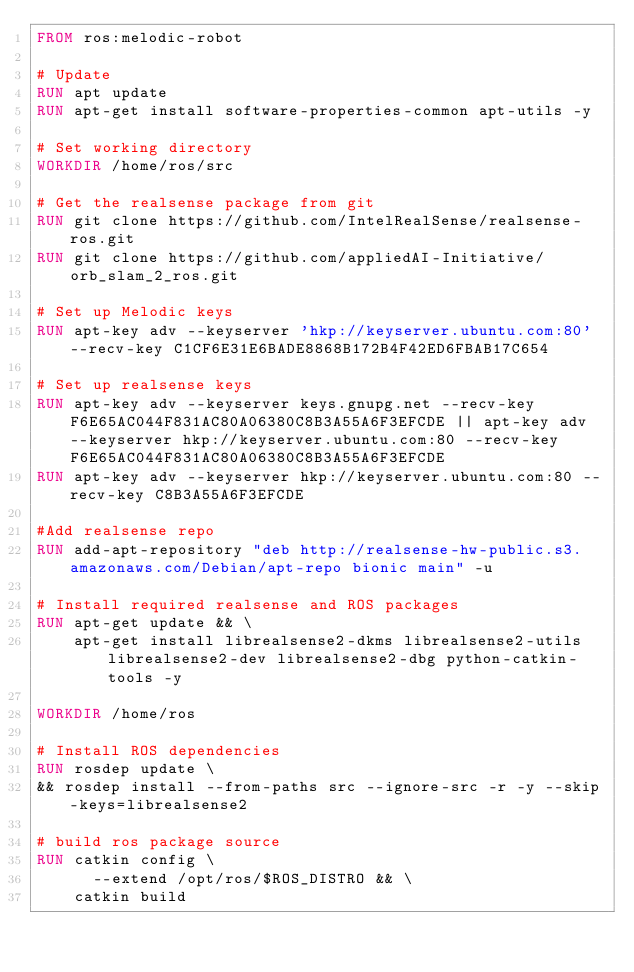Convert code to text. <code><loc_0><loc_0><loc_500><loc_500><_Dockerfile_>FROM ros:melodic-robot

# Update
RUN apt update
RUN apt-get install software-properties-common apt-utils -y

# Set working directory
WORKDIR /home/ros/src

# Get the realsense package from git
RUN git clone https://github.com/IntelRealSense/realsense-ros.git
RUN git clone https://github.com/appliedAI-Initiative/orb_slam_2_ros.git

# Set up Melodic keys
RUN apt-key adv --keyserver 'hkp://keyserver.ubuntu.com:80' --recv-key C1CF6E31E6BADE8868B172B4F42ED6FBAB17C654

# Set up realsense keys
RUN apt-key adv --keyserver keys.gnupg.net --recv-key F6E65AC044F831AC80A06380C8B3A55A6F3EFCDE || apt-key adv --keyserver hkp://keyserver.ubuntu.com:80 --recv-key F6E65AC044F831AC80A06380C8B3A55A6F3EFCDE
RUN apt-key adv --keyserver hkp://keyserver.ubuntu.com:80 --recv-key C8B3A55A6F3EFCDE

#Add realsense repo
RUN add-apt-repository "deb http://realsense-hw-public.s3.amazonaws.com/Debian/apt-repo bionic main" -u

# Install required realsense and ROS packages
RUN apt-get update && \
    apt-get install librealsense2-dkms librealsense2-utils librealsense2-dev librealsense2-dbg python-catkin-tools -y

WORKDIR /home/ros

# Install ROS dependencies
RUN rosdep update \
&& rosdep install --from-paths src --ignore-src -r -y --skip-keys=librealsense2

# build ros package source
RUN catkin config \
      --extend /opt/ros/$ROS_DISTRO && \
    catkin build
</code> 